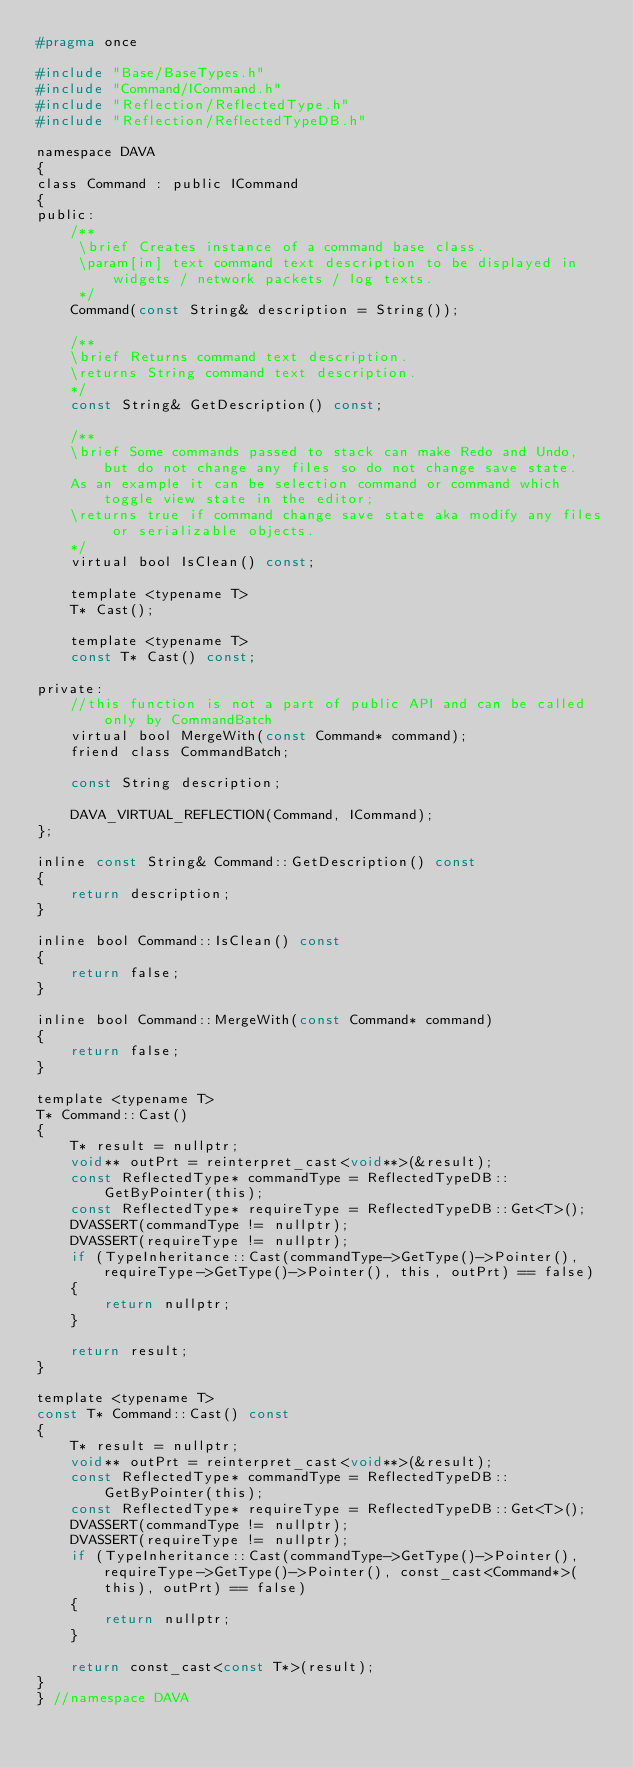Convert code to text. <code><loc_0><loc_0><loc_500><loc_500><_C_>#pragma once

#include "Base/BaseTypes.h"
#include "Command/ICommand.h"
#include "Reflection/ReflectedType.h"
#include "Reflection/ReflectedTypeDB.h"

namespace DAVA
{
class Command : public ICommand
{
public:
    /**
     \brief Creates instance of a command base class.
     \param[in] text command text description to be displayed in widgets / network packets / log texts.
     */
    Command(const String& description = String());

    /**
    \brief Returns command text description.
    \returns String command text description.
    */
    const String& GetDescription() const;

    /**
    \brief Some commands passed to stack can make Redo and Undo, but do not change any files so do not change save state.
    As an example it can be selection command or command which toggle view state in the editor;
    \returns true if command change save state aka modify any files or serializable objects.
    */
    virtual bool IsClean() const;

    template <typename T>
    T* Cast();

    template <typename T>
    const T* Cast() const;

private:
    //this function is not a part of public API and can be called only by CommandBatch
    virtual bool MergeWith(const Command* command);
    friend class CommandBatch;

    const String description;

    DAVA_VIRTUAL_REFLECTION(Command, ICommand);
};

inline const String& Command::GetDescription() const
{
    return description;
}

inline bool Command::IsClean() const
{
    return false;
}

inline bool Command::MergeWith(const Command* command)
{
    return false;
}

template <typename T>
T* Command::Cast()
{
    T* result = nullptr;
    void** outPrt = reinterpret_cast<void**>(&result);
    const ReflectedType* commandType = ReflectedTypeDB::GetByPointer(this);
    const ReflectedType* requireType = ReflectedTypeDB::Get<T>();
    DVASSERT(commandType != nullptr);
    DVASSERT(requireType != nullptr);
    if (TypeInheritance::Cast(commandType->GetType()->Pointer(), requireType->GetType()->Pointer(), this, outPrt) == false)
    {
        return nullptr;
    }

    return result;
}

template <typename T>
const T* Command::Cast() const
{
    T* result = nullptr;
    void** outPrt = reinterpret_cast<void**>(&result);
    const ReflectedType* commandType = ReflectedTypeDB::GetByPointer(this);
    const ReflectedType* requireType = ReflectedTypeDB::Get<T>();
    DVASSERT(commandType != nullptr);
    DVASSERT(requireType != nullptr);
    if (TypeInheritance::Cast(commandType->GetType()->Pointer(), requireType->GetType()->Pointer(), const_cast<Command*>(this), outPrt) == false)
    {
        return nullptr;
    }

    return const_cast<const T*>(result);
}
} //namespace DAVA
</code> 